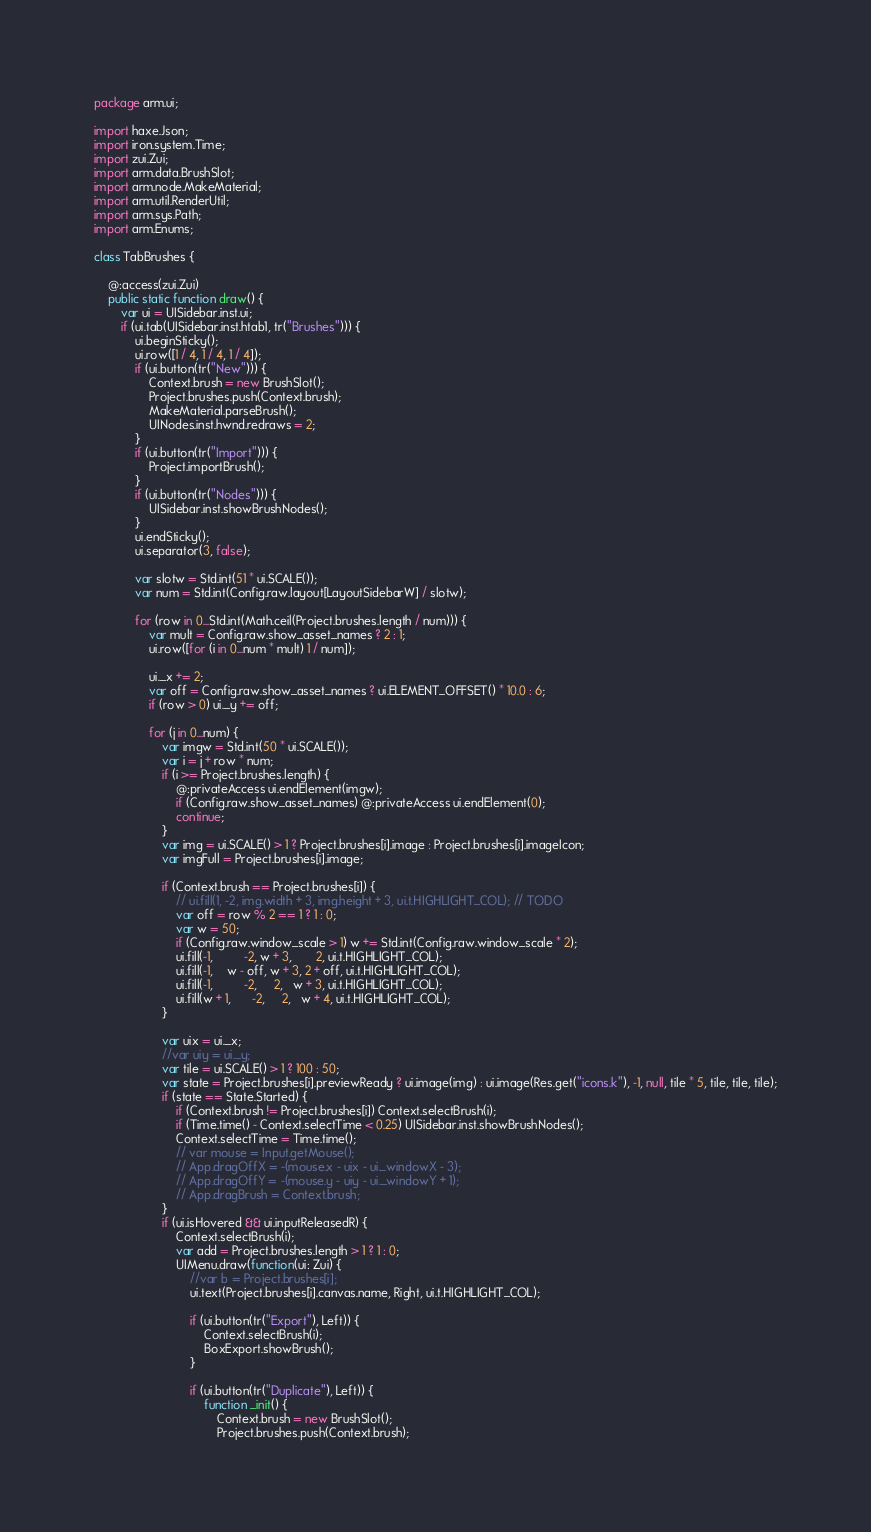<code> <loc_0><loc_0><loc_500><loc_500><_Haxe_>package arm.ui;

import haxe.Json;
import iron.system.Time;
import zui.Zui;
import arm.data.BrushSlot;
import arm.node.MakeMaterial;
import arm.util.RenderUtil;
import arm.sys.Path;
import arm.Enums;

class TabBrushes {

	@:access(zui.Zui)
	public static function draw() {
		var ui = UISidebar.inst.ui;
		if (ui.tab(UISidebar.inst.htab1, tr("Brushes"))) {
			ui.beginSticky();
			ui.row([1 / 4, 1 / 4, 1 / 4]);
			if (ui.button(tr("New"))) {
				Context.brush = new BrushSlot();
				Project.brushes.push(Context.brush);
				MakeMaterial.parseBrush();
				UINodes.inst.hwnd.redraws = 2;
			}
			if (ui.button(tr("Import"))) {
				Project.importBrush();
			}
			if (ui.button(tr("Nodes"))) {
				UISidebar.inst.showBrushNodes();
			}
			ui.endSticky();
			ui.separator(3, false);

			var slotw = Std.int(51 * ui.SCALE());
			var num = Std.int(Config.raw.layout[LayoutSidebarW] / slotw);

			for (row in 0...Std.int(Math.ceil(Project.brushes.length / num))) {
				var mult = Config.raw.show_asset_names ? 2 : 1;
				ui.row([for (i in 0...num * mult) 1 / num]);

				ui._x += 2;
				var off = Config.raw.show_asset_names ? ui.ELEMENT_OFFSET() * 10.0 : 6;
				if (row > 0) ui._y += off;

				for (j in 0...num) {
					var imgw = Std.int(50 * ui.SCALE());
					var i = j + row * num;
					if (i >= Project.brushes.length) {
						@:privateAccess ui.endElement(imgw);
						if (Config.raw.show_asset_names) @:privateAccess ui.endElement(0);
						continue;
					}
					var img = ui.SCALE() > 1 ? Project.brushes[i].image : Project.brushes[i].imageIcon;
					var imgFull = Project.brushes[i].image;

					if (Context.brush == Project.brushes[i]) {
						// ui.fill(1, -2, img.width + 3, img.height + 3, ui.t.HIGHLIGHT_COL); // TODO
						var off = row % 2 == 1 ? 1 : 0;
						var w = 50;
						if (Config.raw.window_scale > 1) w += Std.int(Config.raw.window_scale * 2);
						ui.fill(-1,         -2, w + 3,       2, ui.t.HIGHLIGHT_COL);
						ui.fill(-1,    w - off, w + 3, 2 + off, ui.t.HIGHLIGHT_COL);
						ui.fill(-1,         -2,     2,   w + 3, ui.t.HIGHLIGHT_COL);
						ui.fill(w + 1,      -2,     2,   w + 4, ui.t.HIGHLIGHT_COL);
					}

					var uix = ui._x;
					//var uiy = ui._y;
					var tile = ui.SCALE() > 1 ? 100 : 50;
					var state = Project.brushes[i].previewReady ? ui.image(img) : ui.image(Res.get("icons.k"), -1, null, tile * 5, tile, tile, tile);
					if (state == State.Started) {
						if (Context.brush != Project.brushes[i]) Context.selectBrush(i);
						if (Time.time() - Context.selectTime < 0.25) UISidebar.inst.showBrushNodes();
						Context.selectTime = Time.time();
						// var mouse = Input.getMouse();
						// App.dragOffX = -(mouse.x - uix - ui._windowX - 3);
						// App.dragOffY = -(mouse.y - uiy - ui._windowY + 1);
						// App.dragBrush = Context.brush;
					}
					if (ui.isHovered && ui.inputReleasedR) {
						Context.selectBrush(i);
						var add = Project.brushes.length > 1 ? 1 : 0;
						UIMenu.draw(function(ui: Zui) {
							//var b = Project.brushes[i];
							ui.text(Project.brushes[i].canvas.name, Right, ui.t.HIGHLIGHT_COL);

							if (ui.button(tr("Export"), Left)) {
								Context.selectBrush(i);
								BoxExport.showBrush();
							}

							if (ui.button(tr("Duplicate"), Left)) {
								function _init() {
									Context.brush = new BrushSlot();
									Project.brushes.push(Context.brush);</code> 